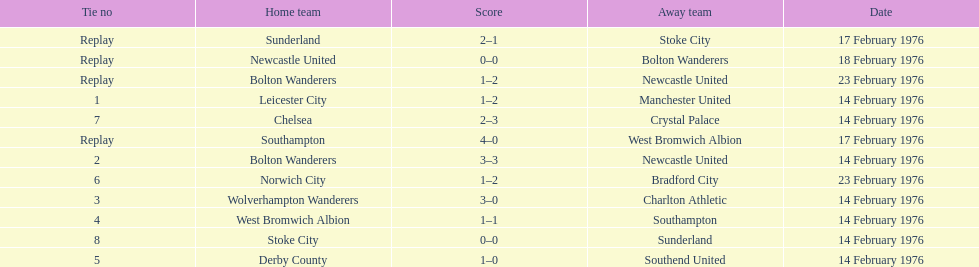Who was the home team in the game on the top of the table? Leicester City. 